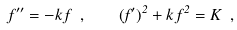Convert formula to latex. <formula><loc_0><loc_0><loc_500><loc_500>f ^ { \prime \prime } = - k \, f \ , \quad ( f ^ { \prime } ) ^ { 2 } + k \, f ^ { 2 } = K \ ,</formula> 